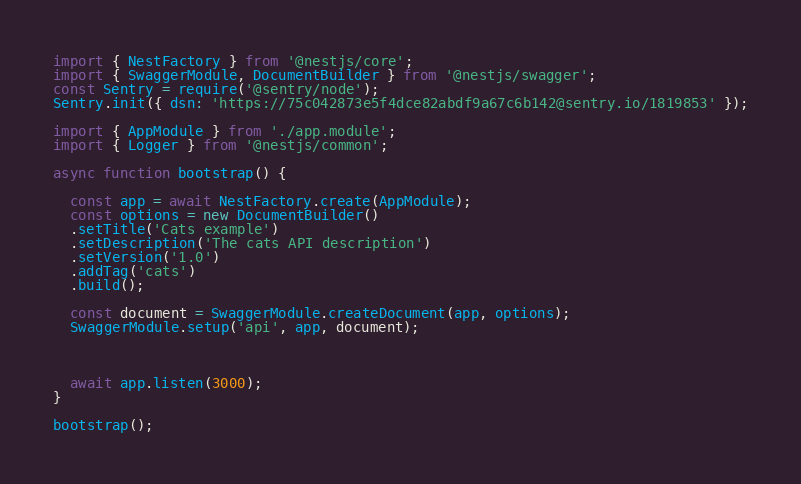<code> <loc_0><loc_0><loc_500><loc_500><_TypeScript_>import { NestFactory } from '@nestjs/core';
import { SwaggerModule, DocumentBuilder } from '@nestjs/swagger';
const Sentry = require('@sentry/node');
Sentry.init({ dsn: 'https://75c042873e5f4dce82abdf9a67c6b142@sentry.io/1819853' });

import { AppModule } from './app.module';
import { Logger } from '@nestjs/common';

async function bootstrap() {
  
  const app = await NestFactory.create(AppModule);
  const options = new DocumentBuilder()
  .setTitle('Cats example')
  .setDescription('The cats API description')
  .setVersion('1.0')
  .addTag('cats')
  .build();

  const document = SwaggerModule.createDocument(app, options);
  SwaggerModule.setup('api', app, document);

  
  
  await app.listen(3000);
}

bootstrap();
</code> 